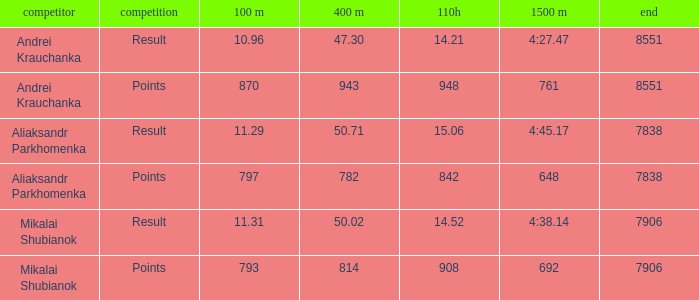What was the 100m that the 110H was less than 14.52 and the 400m was more than 47.3? None. 